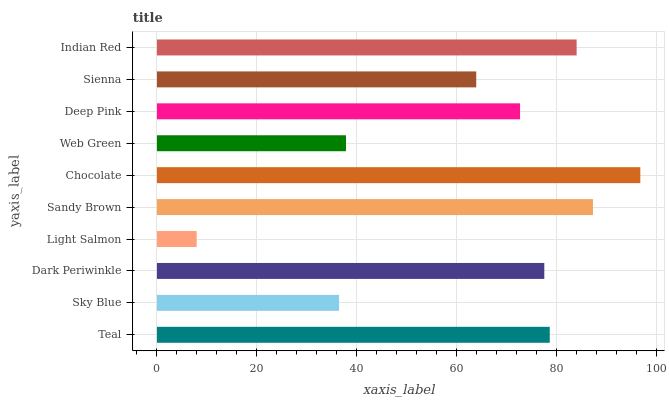Is Light Salmon the minimum?
Answer yes or no. Yes. Is Chocolate the maximum?
Answer yes or no. Yes. Is Sky Blue the minimum?
Answer yes or no. No. Is Sky Blue the maximum?
Answer yes or no. No. Is Teal greater than Sky Blue?
Answer yes or no. Yes. Is Sky Blue less than Teal?
Answer yes or no. Yes. Is Sky Blue greater than Teal?
Answer yes or no. No. Is Teal less than Sky Blue?
Answer yes or no. No. Is Dark Periwinkle the high median?
Answer yes or no. Yes. Is Deep Pink the low median?
Answer yes or no. Yes. Is Teal the high median?
Answer yes or no. No. Is Chocolate the low median?
Answer yes or no. No. 